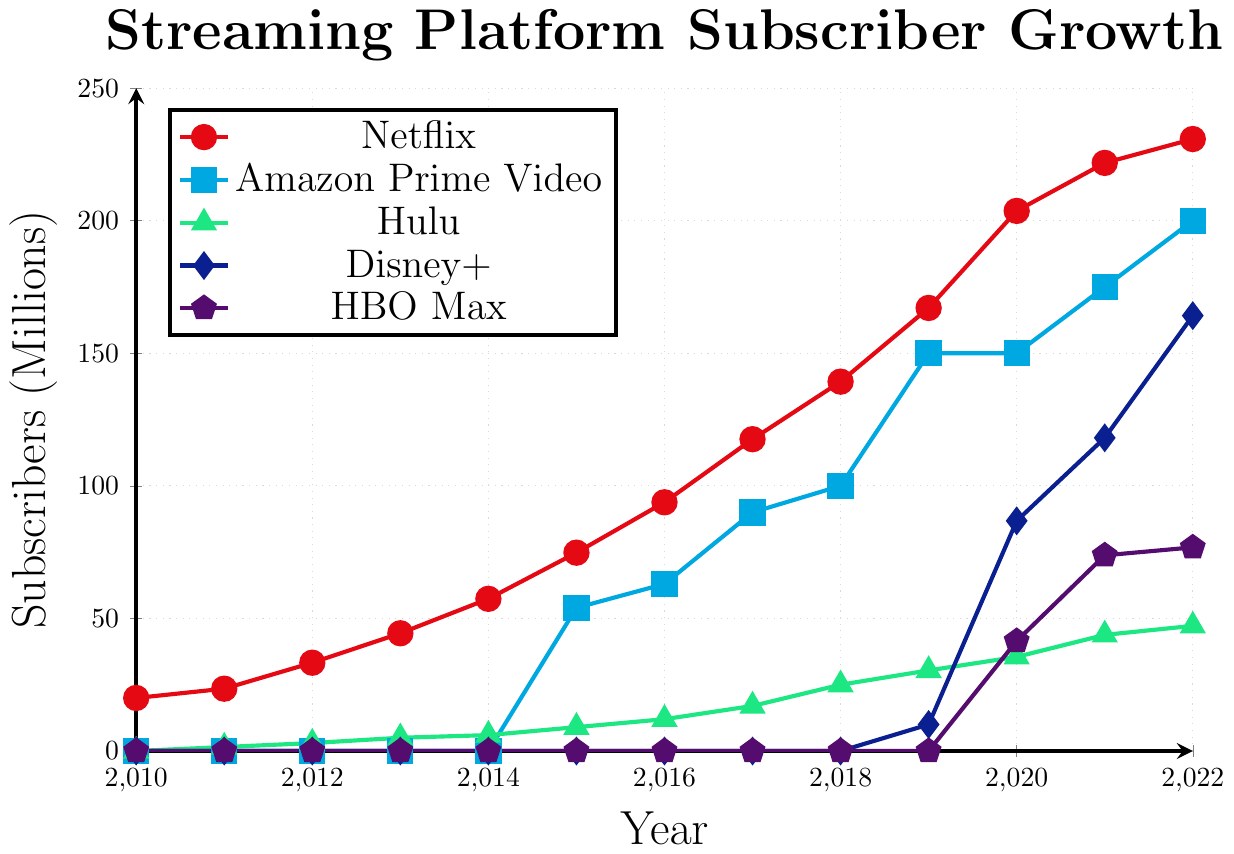Which streaming platform had the most subscribers in 2022? From the plot, identify the point corresponding to 2022 on the x-axis and check the heights for each streaming platform. Netflix clearly has the highest point on the y-axis for 2022.
Answer: Netflix How many more subscribers did Netflix have compared to Amazon Prime Video in 2022? Locate the number of subscribers for Netflix and Amazon Prime Video in 2022 on the plot. Netflix had 230.8 million, and Amazon Prime Video had 200 million. The difference is 230.8 - 200 = 30.8 million.
Answer: 30.8 million Between which two consecutive years did Disney+ see the most significant subscriber growth? Observe the plot for Disney+, noting the steepest increase between two consecutive points. The steepest slope is between 2019 (10 million) and 2020 (86.8 million), indicating the most significant growth.
Answer: 2019 and 2020 What is the average subscriber count for Hulu from 2010 to 2022? Sum the Hulu subscriber counts for each year from 2010 to 2022 and divide by the number of years. Sum = 0 + 1.5 + 3.0 + 5.0 + 6.0 + 9.0 + 12.0 + 17.0 + 25.0 + 30.4 + 35.5 + 43.8 + 47.2 = 235.4. Average = 235.4/13 ≈ 18.1 million.
Answer: 18.1 million Did HBO Max surpass 70 million subscribers before 2021? Check the values for HBO Max at each year. HBO Max first reached above 70 million subscribers in 2021 (73.8 million). Therefore, it did not surpass 70 million subscribers before 2021.
Answer: No How many platforms had over 100 million subscribers in 2021? Evaluate the subscriber counts for each platform in 2021. Netflix (221.8 million), Amazon Prime Video (175 million), and Disney+ (118.1 million) each had over 100 million subscribers, totaling three platforms.
Answer: 3 platforms Compare the subscriber growth rate of Netflix and Hulu between 2015 and 2016. Which platform grew faster? Compute the subscriber increase from 2015 to 2016. Netflix grew from 74.8 to 93.8 million, an increase of 19 million. Hulu grew from 9 to 12 million, an increase of 3 million. Therefore, Netflix grew faster.
Answer: Netflix What was the combined total of all subscribers for the five platforms in 2020? Add the subscribers for all platforms in 2020: Netflix (203.7), Amazon Prime Video (150), Hulu (35.5), Disney+ (86.8), and HBO Max (41.5). Total = 203.7 + 150 + 35.5 + 86.8 + 41.5 = 517.5 million subscribers.
Answer: 517.5 million Which year did Amazon Prime Video reach 100 million subscribers? Find the subscriber count for Amazon Prime Video and identify the year it first equals or surpasses 100 million. According to the plot, it reached 100 million subscribers in 2018.
Answer: 2018 